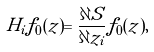<formula> <loc_0><loc_0><loc_500><loc_500>H _ { i } f _ { 0 } ( z ) = \frac { \partial S } { \partial z _ { i } } f _ { 0 } ( z ) ,</formula> 